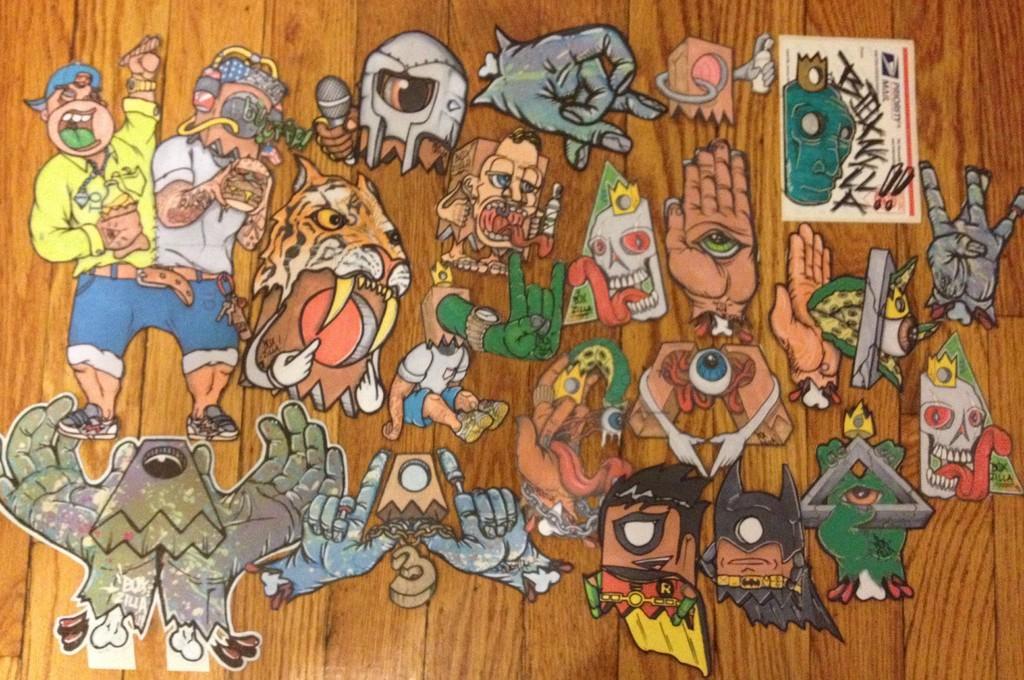How would you summarize this image in a sentence or two? Here in this picture we can see different kind of stickers present on a wooden plank over there. 